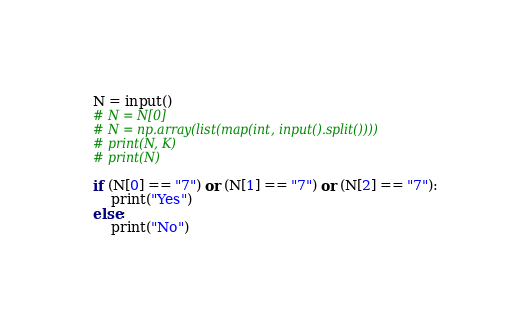<code> <loc_0><loc_0><loc_500><loc_500><_Python_>N = input()
# N = N[0]
# N = np.array(list(map(int, input().split())))
# print(N, K)
# print(N)
 
if (N[0] == "7") or (N[1] == "7") or (N[2] == "7"):
    print("Yes")
else:
    print("No")</code> 